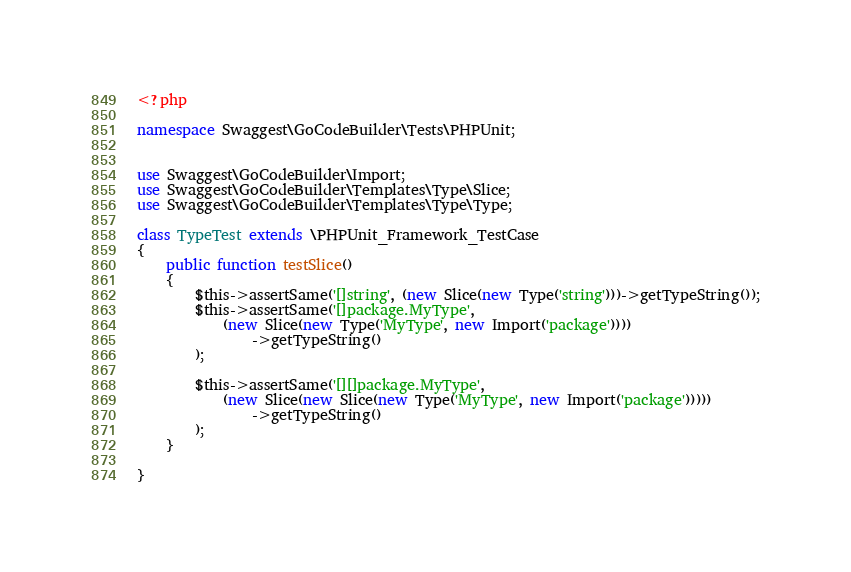<code> <loc_0><loc_0><loc_500><loc_500><_PHP_><?php

namespace Swaggest\GoCodeBuilder\Tests\PHPUnit;


use Swaggest\GoCodeBuilder\Import;
use Swaggest\GoCodeBuilder\Templates\Type\Slice;
use Swaggest\GoCodeBuilder\Templates\Type\Type;

class TypeTest extends \PHPUnit_Framework_TestCase
{
    public function testSlice()
    {
        $this->assertSame('[]string', (new Slice(new Type('string')))->getTypeString());
        $this->assertSame('[]package.MyType',
            (new Slice(new Type('MyType', new Import('package'))))
                ->getTypeString()
        );

        $this->assertSame('[][]package.MyType',
            (new Slice(new Slice(new Type('MyType', new Import('package')))))
                ->getTypeString()
        );
    }

}</code> 